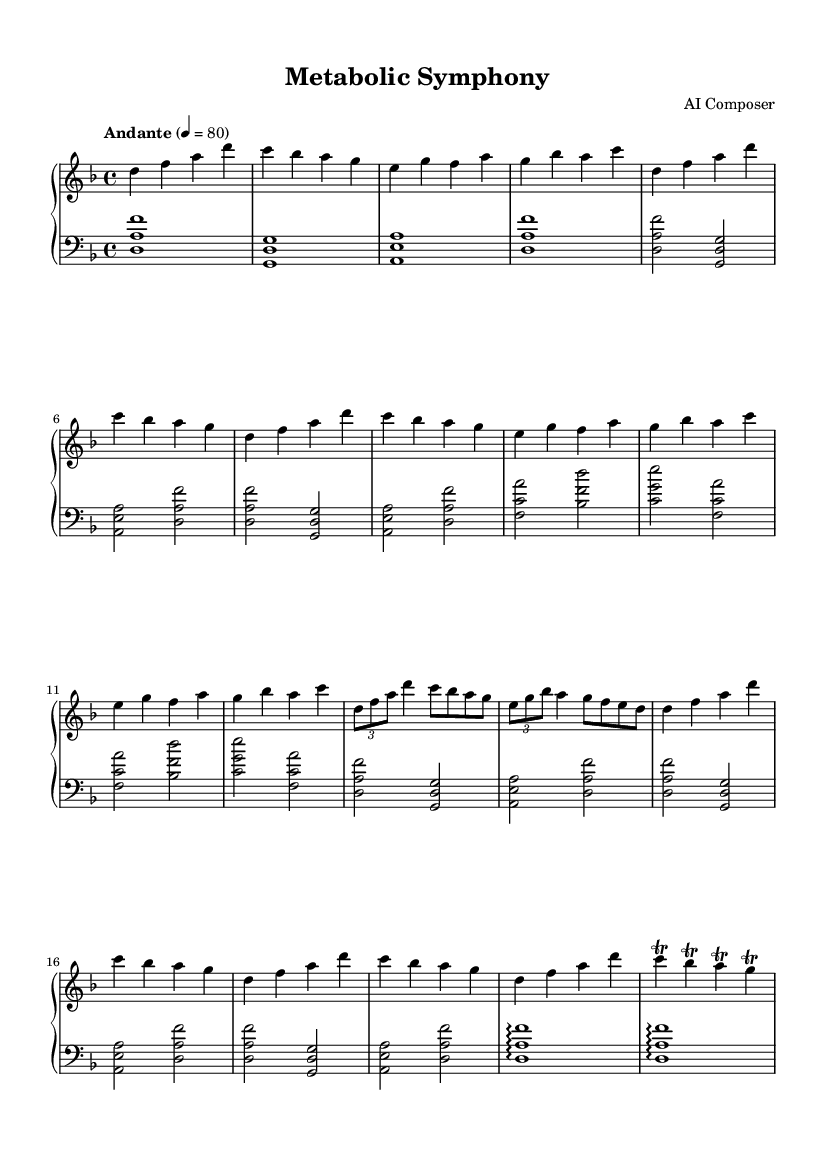What is the key signature of this music? The key signature is indicated by the presence of one flat (B flat) in the notation, which can be verified from the global declaration at the beginning of the code.
Answer: D minor What is the time signature of this piece? The time signature is given as "4/4" in the global declaration, indicating that there are four beats per measure and a quarter note gets one beat.
Answer: 4/4 What is the tempo marking of this composition? The tempo marking "Andante" indicates a moderate walking pace, which is stated in the global parameters at the beginning of the piece, alongside the metronome mark of "4 = 80".
Answer: Andante How many measures are there in Theme A? Theme A consists of four measures, identified by the progression of notes between the specified sections in the right-hand part of the code.
Answer: 4 What type of musical structure does this piece primarily utilize? The piece is structured with sections comprising an introduction, themes, development, recapitulation, and a coda. This structure is determined by observing the layout of sections as specified in the code.
Answer: Sonata form What motifs are represented in Theme B? Theme B features an "Enzyme Motif," characterized by a distinct melodic progression exhibited in the right-hand part of the code, focusing on the notes E, G, F, and A.
Answer: Enzyme Motif How is the emotional tone conveyed in the Coda? The Coda conveys emotional resolution through the use of arpeggiated phrases and trills, creating a sense of closure which can be identified in the final measures of both the left and right-hand parts.
Answer: Resolution 